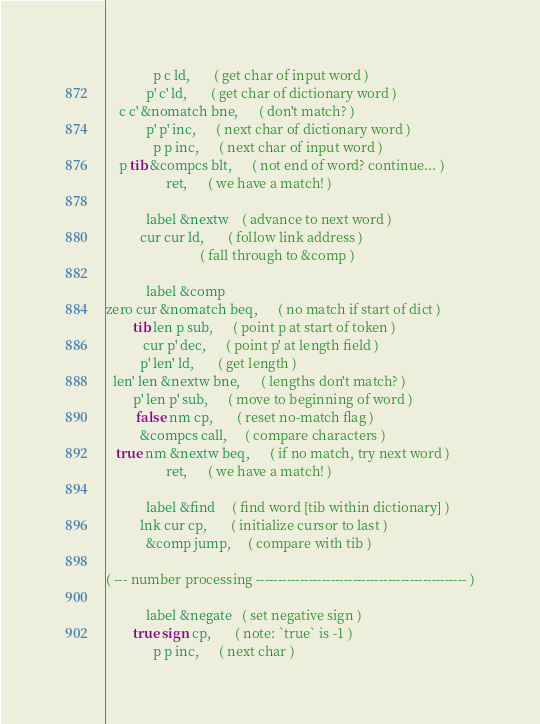Convert code to text. <code><loc_0><loc_0><loc_500><loc_500><_Forth_>              p c ld,       ( get char of input word )
            p' c' ld,       ( get char of dictionary word )
    c c' &nomatch bne,      ( don't match? )
            p' p' inc,      ( next char of dictionary word )
              p p inc,      ( next char of input word )
    p tib &compcs blt,      ( not end of word? continue... )
                  ret,      ( we have a match! )
      
            label &nextw    ( advance to next word )
          cur cur ld,       ( follow link address )
                            ( fall through to &comp )
      
            label &comp
zero cur &nomatch beq,      ( no match if start of dict )
        tib len p sub,      ( point p at start of token )
           cur p' dec,      ( point p' at length field )
          p' len' ld,       ( get length )
  len' len &nextw bne,      ( lengths don't match? )
        p' len p' sub,      ( move to beginning of word )
         false nm cp,       ( reset no-match flag )
          &compcs call,     ( compare characters )
   true nm &nextw beq,      ( if no match, try next word )
                  ret,      ( we have a match! )
                  
            label &find     ( find word [tib within dictionary] )
          lnk cur cp,       ( initialize cursor to last )
            &comp jump,     ( compare with tib )
      
( --- number processing ------------------------------------------------ )

            label &negate   ( set negative sign )
        true sign cp,       ( note: `true` is -1 )
              p p inc,      ( next char )</code> 